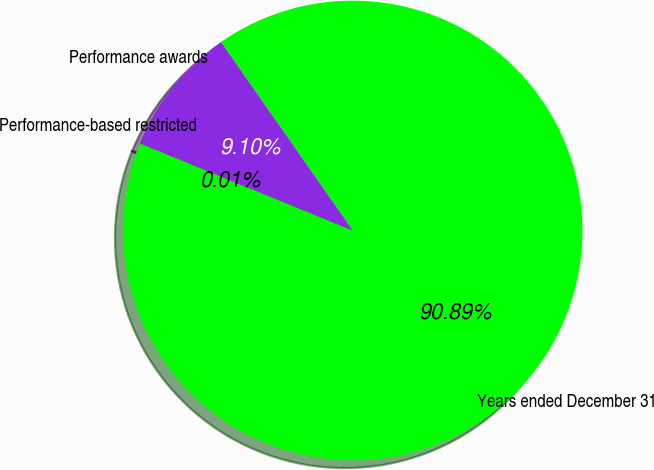Convert chart to OTSL. <chart><loc_0><loc_0><loc_500><loc_500><pie_chart><fcel>Years ended December 31<fcel>Performance awards<fcel>Performance-based restricted<nl><fcel>90.89%<fcel>9.1%<fcel>0.01%<nl></chart> 